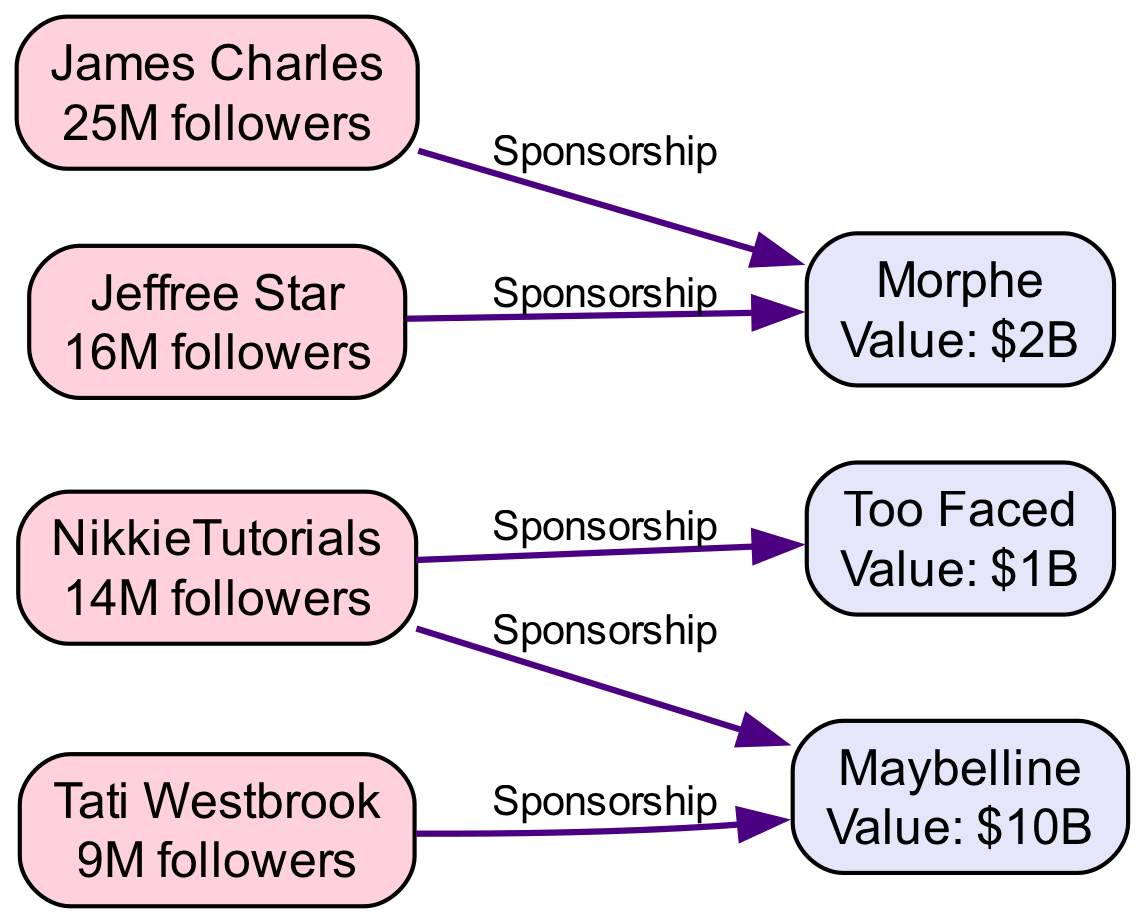What is the market value of Maybelline? The diagram indicates that Maybelline has a market value of $10B, which is directly stated next to the node representing Maybelline as a Cosmetic Company.
Answer: $10B Who has 25M followers? The node for James Charles shows that he is a Beauty Influencer with 25M followers.
Answer: James Charles How many sponsorships are listed in total? By counting the relationships/edges in the diagram, there are 5 distinct sponsorship connections between beauty influencers and cosmetic companies.
Answer: 5 Which influencer partnered with Too Faced? The relationship from NikkieTutorials to Too Faced indicates that she partnered with them for product launches. This connects the two nodes through a sponsorship relationship.
Answer: NikkieTutorials What relationship does Tati Westbrook have with Maybelline? The diagram shows that Tati Westbrook has a sponsorship relationship with Maybelline, where she has been a brand ambassador. This connects her as a Beauty Influencer to the company Maybelline.
Answer: Sponsorship Which cosmetic company is associated with both NikkieTutorials and Morphe? By examining the relationships, NikkieTutorials has collaborated with Maybelline while James Charles and Jeffree Star are associated only with Morphe. Therefore, the only company connected to both influencers is Morphe.
Answer: Morphe Who collaborated with Morphe to create a makeup palette? The relationship line identifies that James Charles collaborated with Morphe specifically to create a makeup palette, which is documented in the relationships section.
Answer: James Charles Which influencer has the least number of followers? The follower counts on the nodes reveal that Tati Westbrook has 9M followers, making her the influencer with the least followers according to the provided data.
Answer: Tati Westbrook 